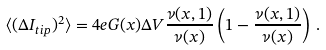Convert formula to latex. <formula><loc_0><loc_0><loc_500><loc_500>\langle ( \Delta I _ { t i p } ) ^ { 2 } \rangle = 4 e G ( x ) \Delta V \frac { \nu ( x , 1 ) } { \nu ( x ) } \left ( 1 - \frac { \nu ( x , 1 ) } { \nu ( x ) } \right ) \, .</formula> 